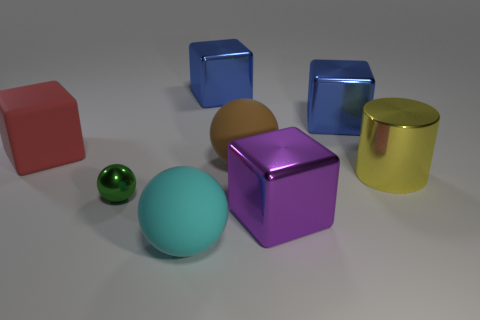Add 1 cylinders. How many objects exist? 9 Subtract all balls. How many objects are left? 5 Add 5 small gray metal balls. How many small gray metal balls exist? 5 Subtract 0 red balls. How many objects are left? 8 Subtract all small purple cylinders. Subtract all metal objects. How many objects are left? 3 Add 6 large blue cubes. How many large blue cubes are left? 8 